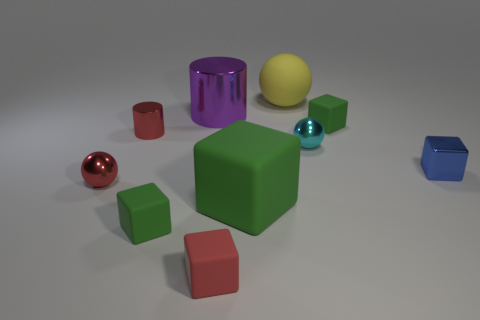What number of other things are there of the same color as the small cylinder?
Provide a succinct answer. 2. There is a small green object right of the large purple shiny thing; what is its shape?
Provide a short and direct response. Cube. Does the red shiny ball have the same size as the purple metal thing that is in front of the matte sphere?
Your answer should be compact. No. Are there any green things that have the same material as the red cube?
Provide a succinct answer. Yes. What number of spheres are small shiny objects or big matte objects?
Offer a very short reply. 3. There is a tiny green cube on the left side of the large green block; is there a blue metallic cube that is behind it?
Your answer should be compact. Yes. Are there fewer yellow cylinders than tiny cylinders?
Offer a terse response. Yes. How many matte objects are the same shape as the big purple shiny object?
Offer a very short reply. 0. How many gray things are either big matte cubes or matte blocks?
Your response must be concise. 0. What size is the metal object that is behind the red metallic object to the right of the red shiny ball?
Give a very brief answer. Large. 